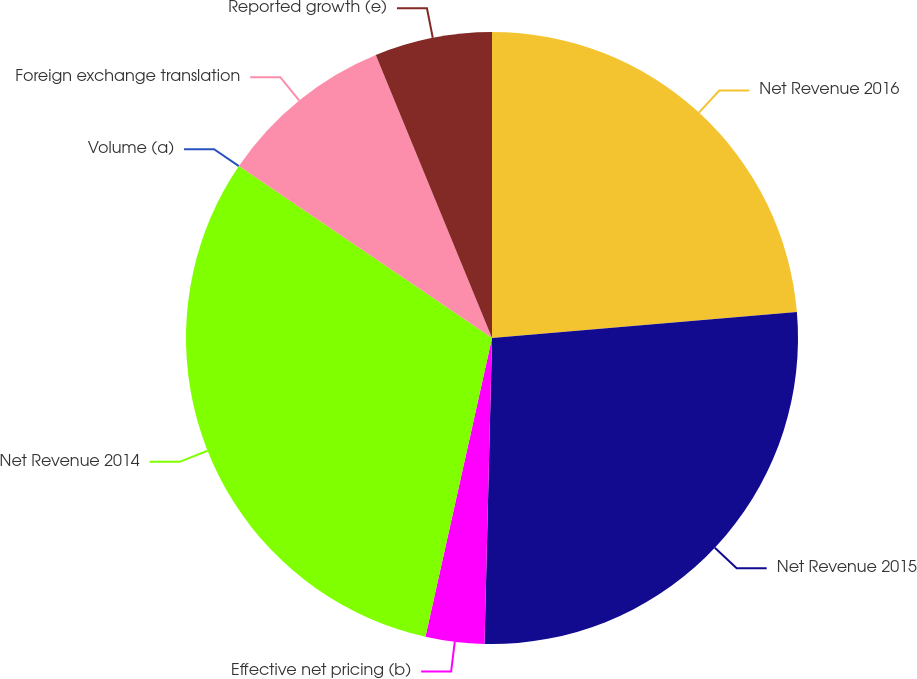<chart> <loc_0><loc_0><loc_500><loc_500><pie_chart><fcel>Net Revenue 2016<fcel>Net Revenue 2015<fcel>Effective net pricing (b)<fcel>Net Revenue 2014<fcel>Volume (a)<fcel>Foreign exchange translation<fcel>Reported growth (e)<nl><fcel>23.64%<fcel>26.74%<fcel>3.1%<fcel>31.0%<fcel>0.0%<fcel>9.3%<fcel>6.2%<nl></chart> 